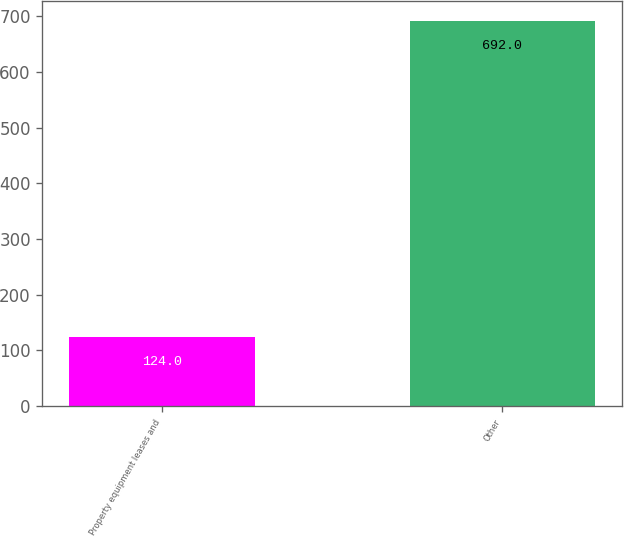Convert chart to OTSL. <chart><loc_0><loc_0><loc_500><loc_500><bar_chart><fcel>Property equipment leases and<fcel>Other<nl><fcel>124<fcel>692<nl></chart> 